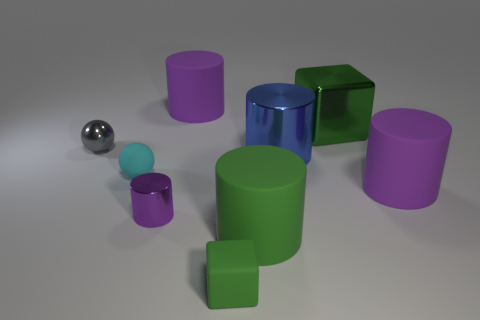What number of red cylinders are there?
Make the answer very short. 0. There is a big purple rubber object that is in front of the big purple cylinder that is to the left of the big purple rubber cylinder that is in front of the tiny cyan matte object; what shape is it?
Provide a short and direct response. Cylinder. Is the number of small metal cylinders that are right of the small matte cube less than the number of large things that are to the left of the blue object?
Your answer should be very brief. Yes. Does the tiny rubber thing that is in front of the large green matte cylinder have the same shape as the tiny shiny thing that is in front of the gray object?
Keep it short and to the point. No. What is the shape of the thing right of the green object behind the tiny purple shiny cylinder?
Offer a terse response. Cylinder. What is the size of the other block that is the same color as the small rubber cube?
Ensure brevity in your answer.  Large. Are there any cyan spheres made of the same material as the gray object?
Your answer should be compact. No. There is a small ball that is left of the small cyan object; what is it made of?
Provide a succinct answer. Metal. What material is the small gray ball?
Keep it short and to the point. Metal. Is the material of the block that is in front of the green rubber cylinder the same as the green cylinder?
Your answer should be very brief. Yes. 